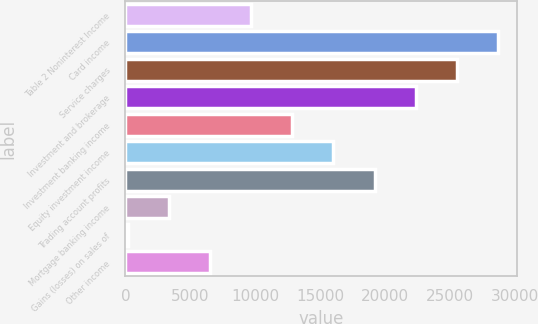Convert chart to OTSL. <chart><loc_0><loc_0><loc_500><loc_500><bar_chart><fcel>Table 2 Noninterest Income<fcel>Card income<fcel>Service charges<fcel>Investment and brokerage<fcel>Investment banking income<fcel>Equity investment income<fcel>Trading account profits<fcel>Mortgage banking income<fcel>Gains (losses) on sales of<fcel>Other income<nl><fcel>9691.8<fcel>28715.4<fcel>25544.8<fcel>22374.2<fcel>12862.4<fcel>16033<fcel>19203.6<fcel>3350.6<fcel>180<fcel>6521.2<nl></chart> 